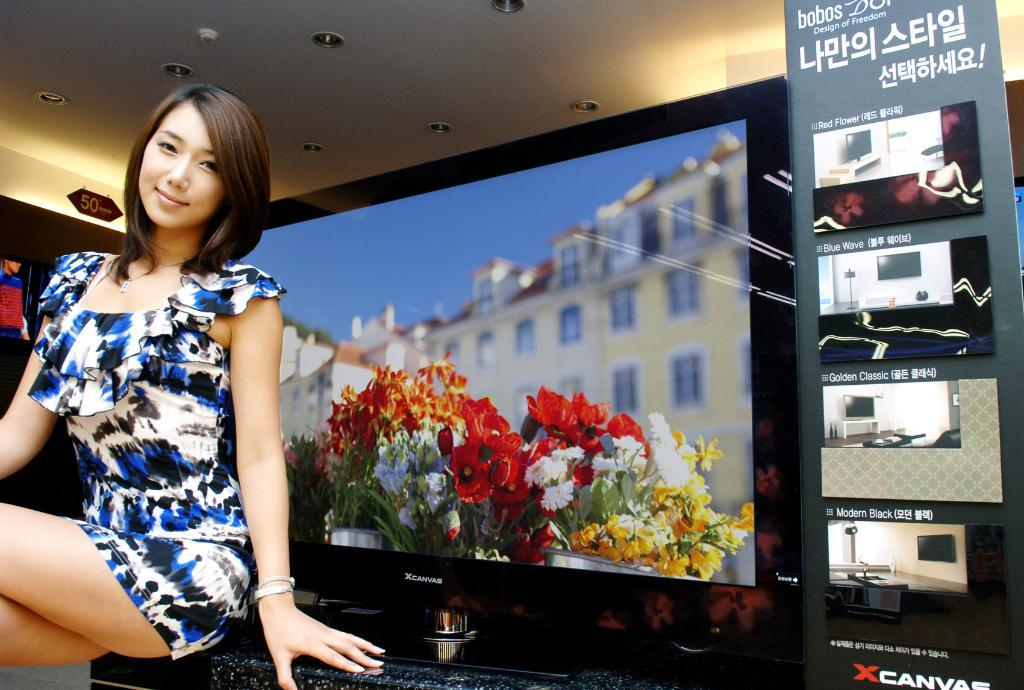Provide a one-sentence caption for the provided image. The woman is probably a model for the XCanvas televisions. 